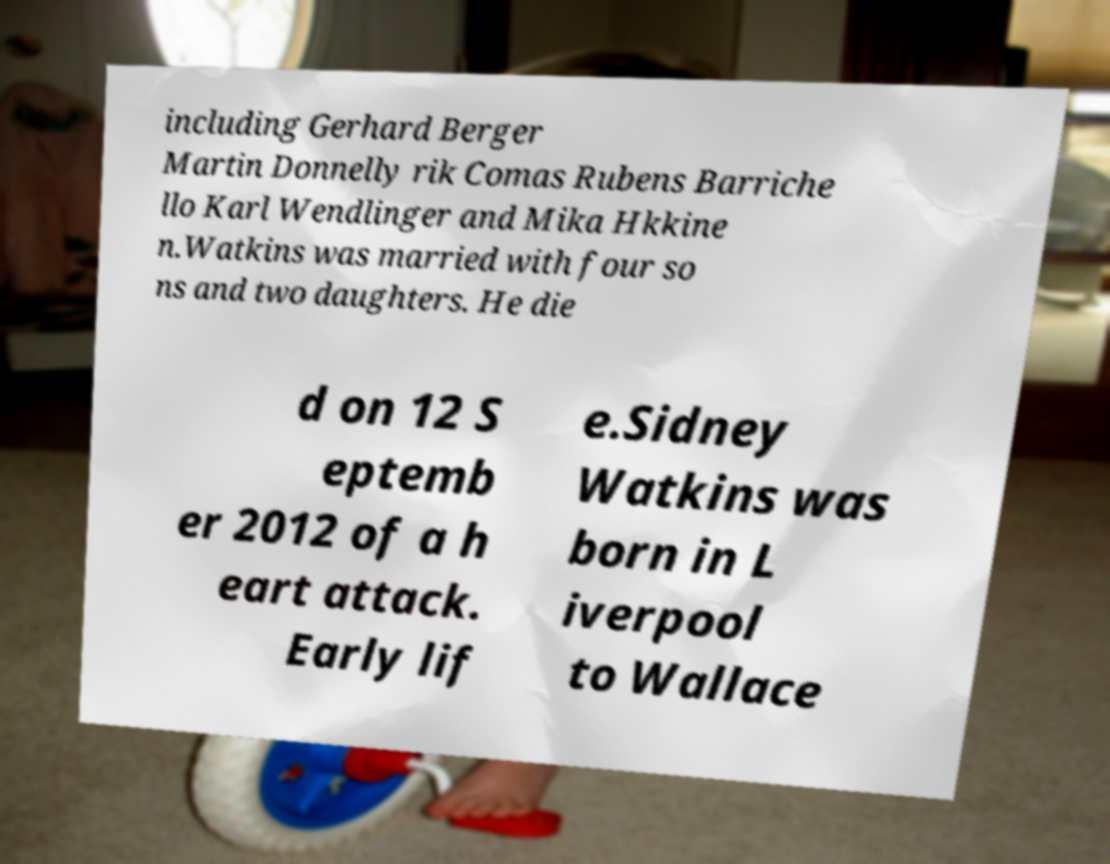Could you assist in decoding the text presented in this image and type it out clearly? including Gerhard Berger Martin Donnelly rik Comas Rubens Barriche llo Karl Wendlinger and Mika Hkkine n.Watkins was married with four so ns and two daughters. He die d on 12 S eptemb er 2012 of a h eart attack. Early lif e.Sidney Watkins was born in L iverpool to Wallace 